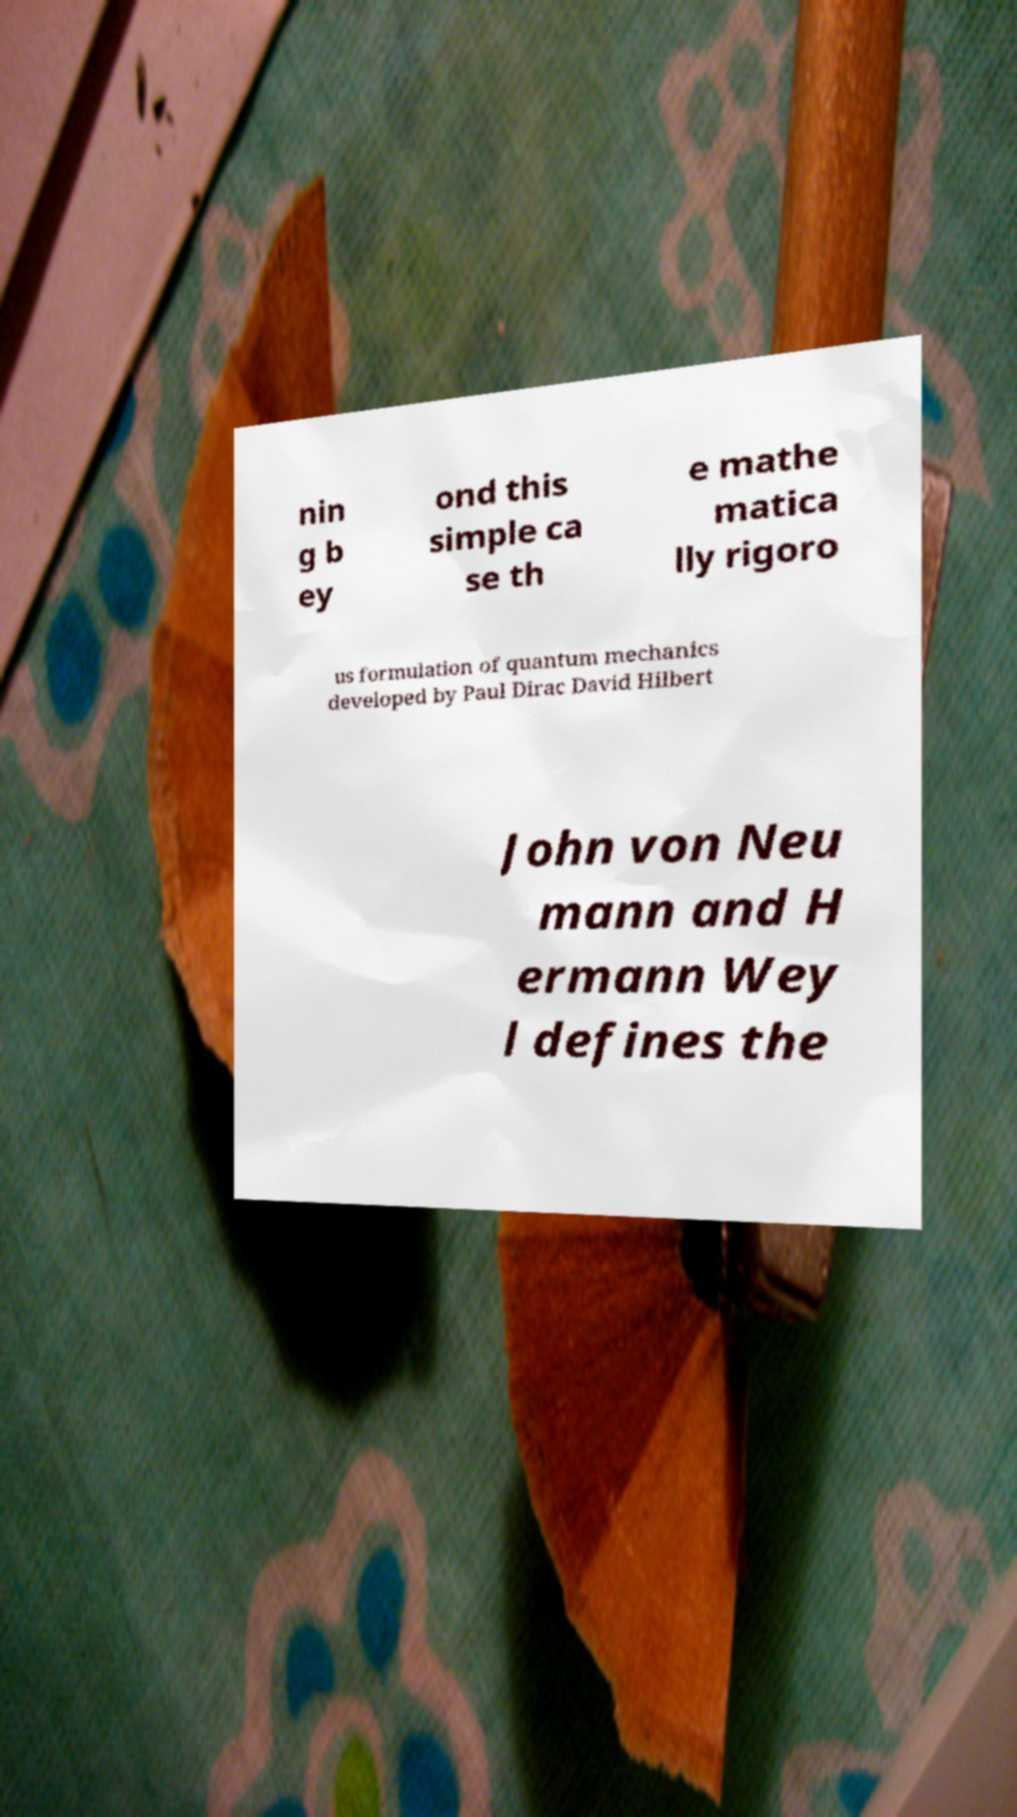There's text embedded in this image that I need extracted. Can you transcribe it verbatim? nin g b ey ond this simple ca se th e mathe matica lly rigoro us formulation of quantum mechanics developed by Paul Dirac David Hilbert John von Neu mann and H ermann Wey l defines the 